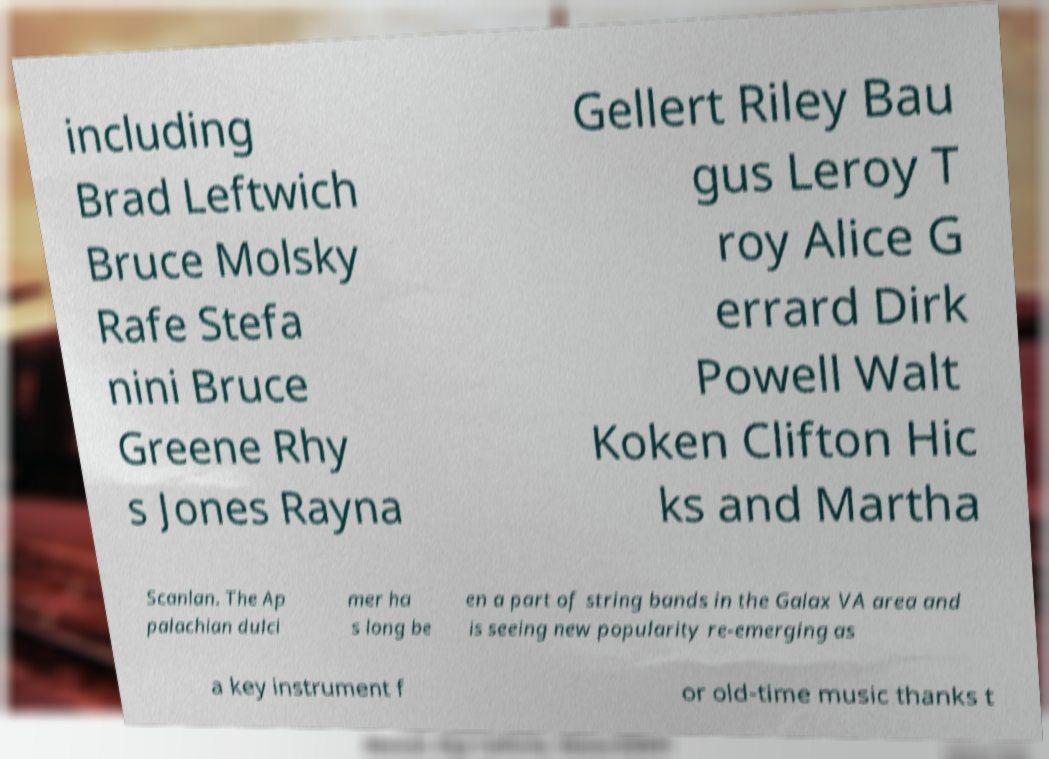For documentation purposes, I need the text within this image transcribed. Could you provide that? including Brad Leftwich Bruce Molsky Rafe Stefa nini Bruce Greene Rhy s Jones Rayna Gellert Riley Bau gus Leroy T roy Alice G errard Dirk Powell Walt Koken Clifton Hic ks and Martha Scanlan. The Ap palachian dulci mer ha s long be en a part of string bands in the Galax VA area and is seeing new popularity re-emerging as a key instrument f or old-time music thanks t 